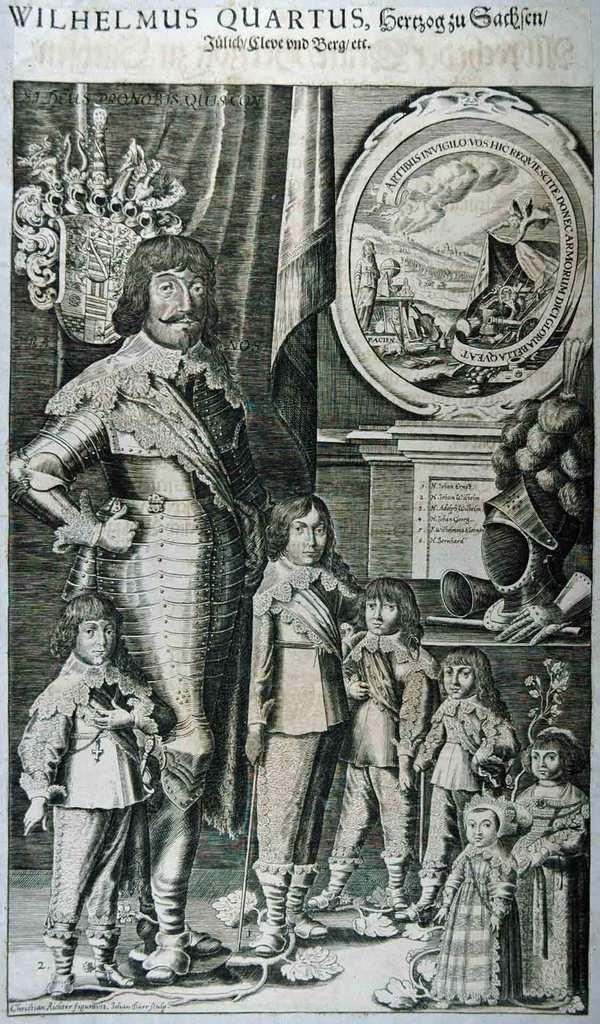Please provide a concise description of this image. This is a black and white image. In this image we can see the picture of a group of people standing on the floor. On the backside we can see a curtain, a photo frame on a wall and some objects placed on the table. On the top of the image we can see some text. 